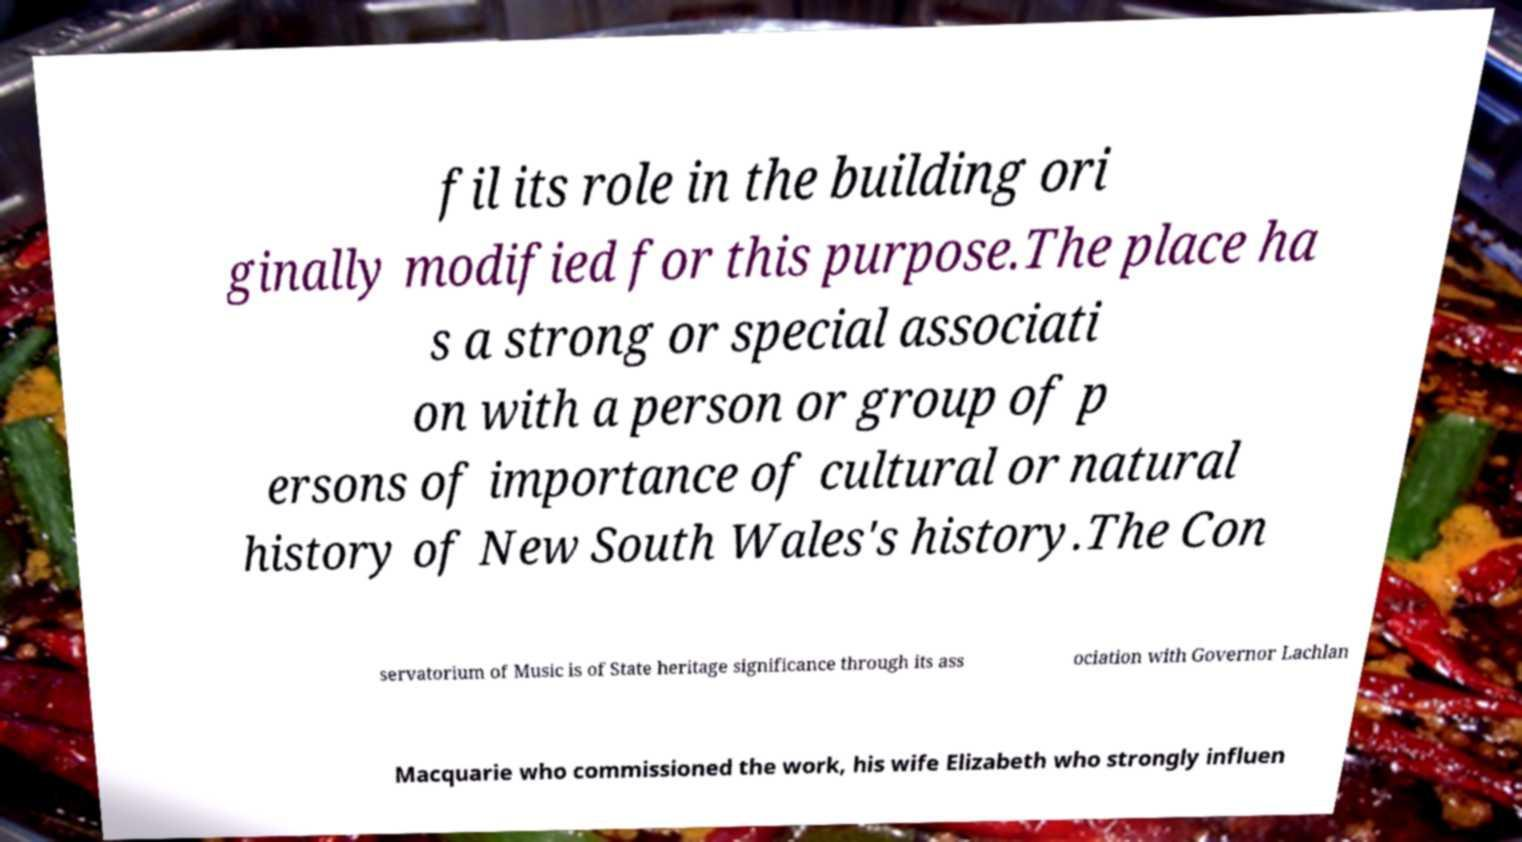Could you extract and type out the text from this image? fil its role in the building ori ginally modified for this purpose.The place ha s a strong or special associati on with a person or group of p ersons of importance of cultural or natural history of New South Wales's history.The Con servatorium of Music is of State heritage significance through its ass ociation with Governor Lachlan Macquarie who commissioned the work, his wife Elizabeth who strongly influen 